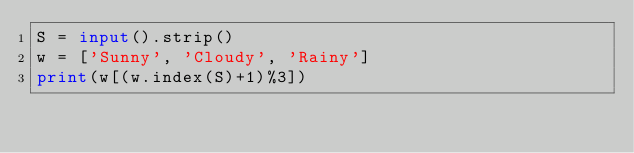<code> <loc_0><loc_0><loc_500><loc_500><_Python_>S = input().strip()
w = ['Sunny', 'Cloudy', 'Rainy']
print(w[(w.index(S)+1)%3])
</code> 